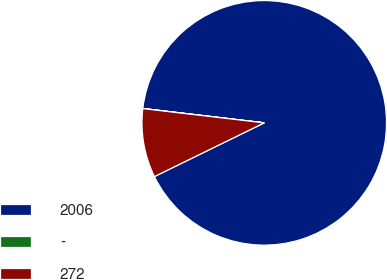Convert chart to OTSL. <chart><loc_0><loc_0><loc_500><loc_500><pie_chart><fcel>2006<fcel>-<fcel>272<nl><fcel>90.88%<fcel>0.02%<fcel>9.1%<nl></chart> 